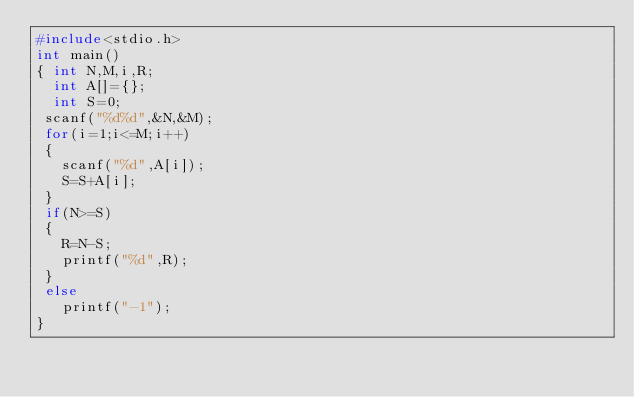<code> <loc_0><loc_0><loc_500><loc_500><_C_>#include<stdio.h>
int main()
{ int N,M,i,R;
  int A[]={};
  int S=0;
 scanf("%d%d",&N,&M);
 for(i=1;i<=M;i++)
 {
   scanf("%d",A[i]);
   S=S+A[i];
 }
 if(N>=S)
 {
   R=N-S;
   printf("%d",R);
 }
 else
   printf("-1");
}
 
</code> 